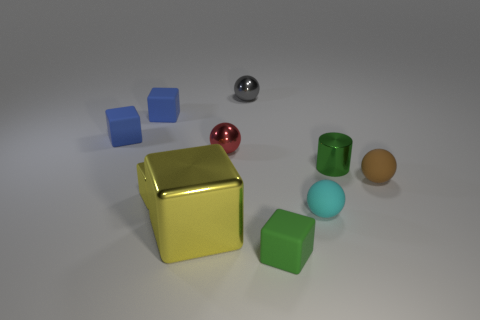Subtract all cyan spheres. How many spheres are left? 3 Subtract all brown balls. How many balls are left? 3 Subtract 3 cubes. How many cubes are left? 2 Subtract all blue rubber blocks. Subtract all green metal objects. How many objects are left? 7 Add 7 gray balls. How many gray balls are left? 8 Add 1 tiny green cubes. How many tiny green cubes exist? 2 Subtract 0 gray blocks. How many objects are left? 10 Subtract all cylinders. How many objects are left? 9 Subtract all blue cubes. Subtract all yellow spheres. How many cubes are left? 3 Subtract all green cylinders. How many green blocks are left? 1 